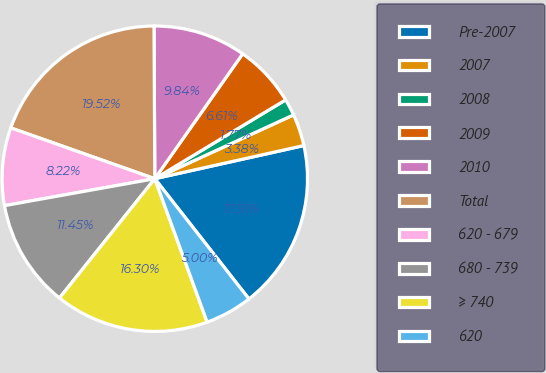<chart> <loc_0><loc_0><loc_500><loc_500><pie_chart><fcel>Pre-2007<fcel>2007<fcel>2008<fcel>2009<fcel>2010<fcel>Total<fcel>620 - 679<fcel>680 - 739<fcel>≥ 740<fcel>620<nl><fcel>17.91%<fcel>3.38%<fcel>1.77%<fcel>6.61%<fcel>9.84%<fcel>19.52%<fcel>8.22%<fcel>11.45%<fcel>16.3%<fcel>5.0%<nl></chart> 